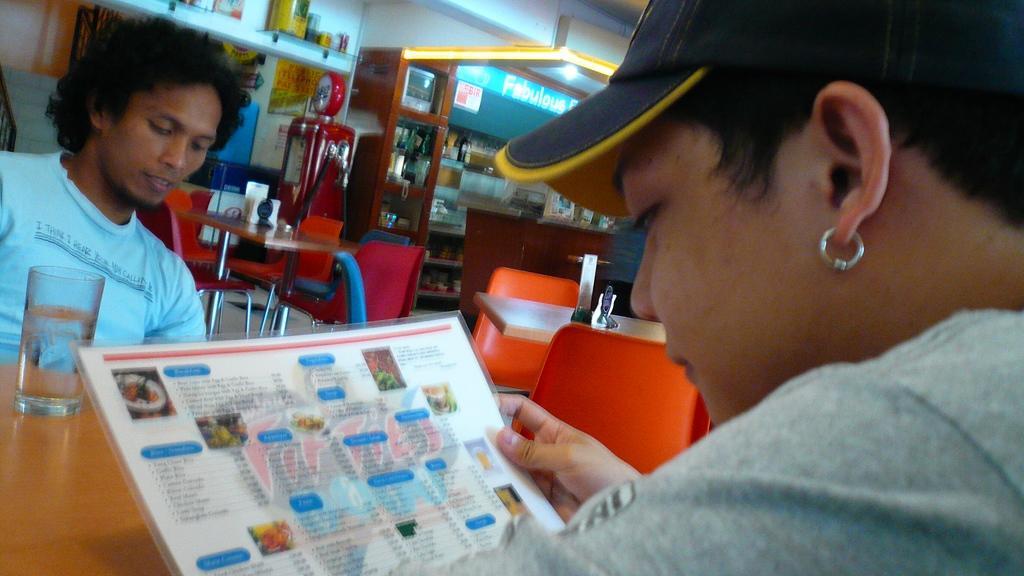How would you summarize this image in a sentence or two? In this picture we can observe two persons sitting in front of each other in the chairs. There is a brown color table in between them. We can observe a glass on the table. There is a menu card in one of the person's hand. In the background there are some empty chairs. We can observe a wall which is in white color in the background. There is a brown color desk. 